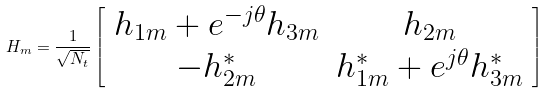<formula> <loc_0><loc_0><loc_500><loc_500>H _ { m } = \frac { 1 } { \sqrt { N _ { t } } } \left [ \begin{array} { c c } h _ { 1 m } + e ^ { - j \theta } h _ { 3 m } & h _ { 2 m } \\ - h _ { 2 m } ^ { * } & h _ { 1 m } ^ { * } + e ^ { j \theta } h _ { 3 m } ^ { * } \end{array} \right ]</formula> 